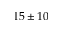Convert formula to latex. <formula><loc_0><loc_0><loc_500><loc_500>1 5 \pm 1 0</formula> 